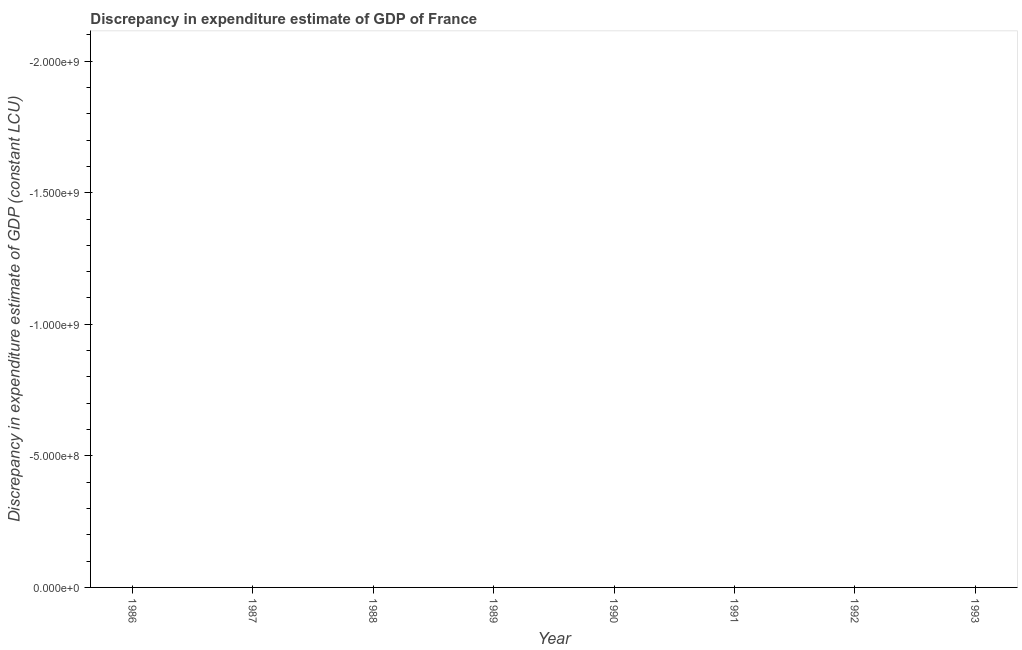What is the discrepancy in expenditure estimate of gdp in 1992?
Make the answer very short. 0. Across all years, what is the minimum discrepancy in expenditure estimate of gdp?
Offer a terse response. 0. What is the average discrepancy in expenditure estimate of gdp per year?
Offer a terse response. 0. What is the median discrepancy in expenditure estimate of gdp?
Your response must be concise. 0. In how many years, is the discrepancy in expenditure estimate of gdp greater than -400000000 LCU?
Offer a very short reply. 0. In how many years, is the discrepancy in expenditure estimate of gdp greater than the average discrepancy in expenditure estimate of gdp taken over all years?
Provide a short and direct response. 0. Does the discrepancy in expenditure estimate of gdp monotonically increase over the years?
Your answer should be very brief. No. How many years are there in the graph?
Provide a short and direct response. 8. Does the graph contain grids?
Make the answer very short. No. What is the title of the graph?
Your response must be concise. Discrepancy in expenditure estimate of GDP of France. What is the label or title of the X-axis?
Your answer should be very brief. Year. What is the label or title of the Y-axis?
Your answer should be very brief. Discrepancy in expenditure estimate of GDP (constant LCU). What is the Discrepancy in expenditure estimate of GDP (constant LCU) in 1986?
Offer a terse response. 0. What is the Discrepancy in expenditure estimate of GDP (constant LCU) of 1987?
Keep it short and to the point. 0. What is the Discrepancy in expenditure estimate of GDP (constant LCU) of 1990?
Ensure brevity in your answer.  0. What is the Discrepancy in expenditure estimate of GDP (constant LCU) in 1992?
Your response must be concise. 0. What is the Discrepancy in expenditure estimate of GDP (constant LCU) of 1993?
Ensure brevity in your answer.  0. 